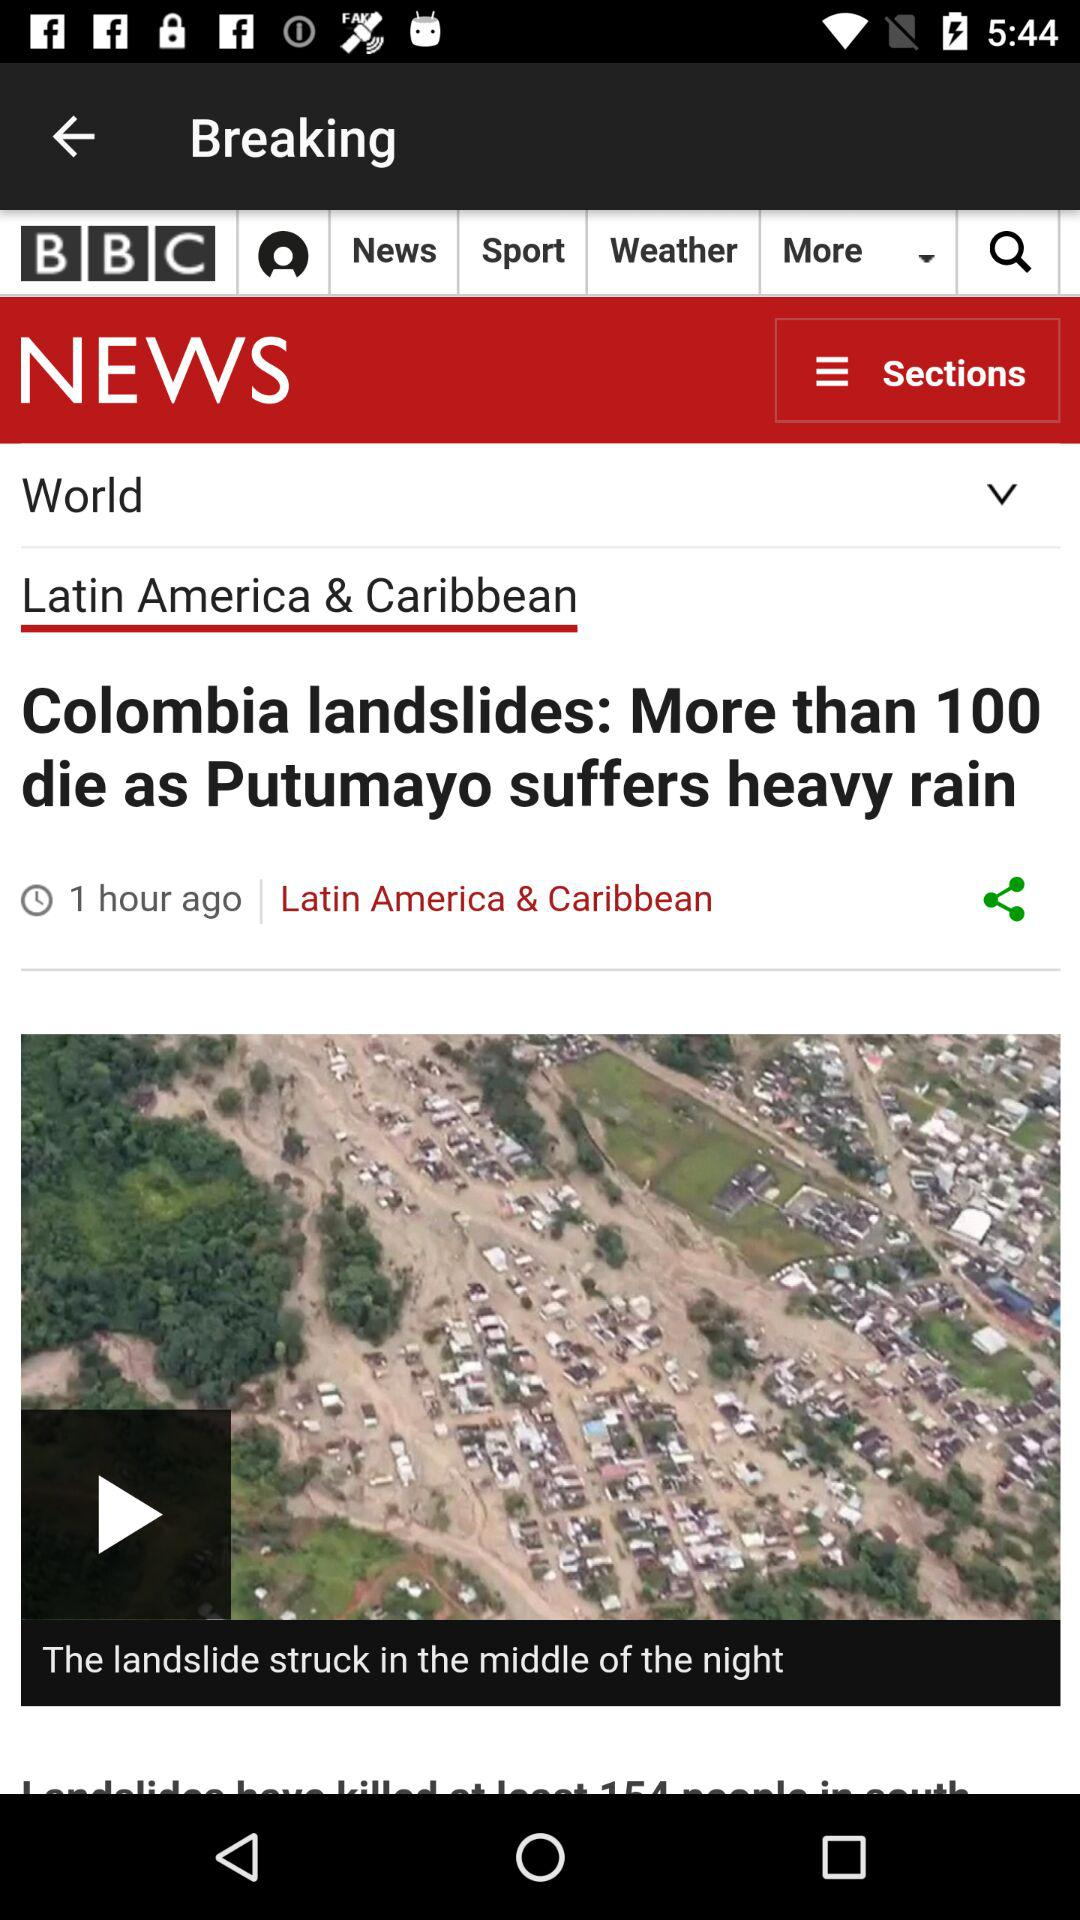How many hours ago did the Colombia landslide news come out? The Colombia landslide news came out 1 hour ago. 